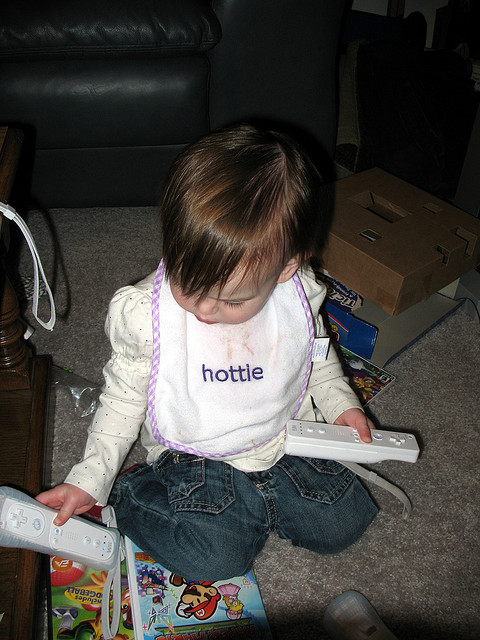Extract all visible text content from this image. hottie 